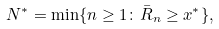Convert formula to latex. <formula><loc_0><loc_0><loc_500><loc_500>N ^ { * } = \min \{ n \geq 1 \colon \bar { R } _ { n } \geq x ^ { * } \} ,</formula> 